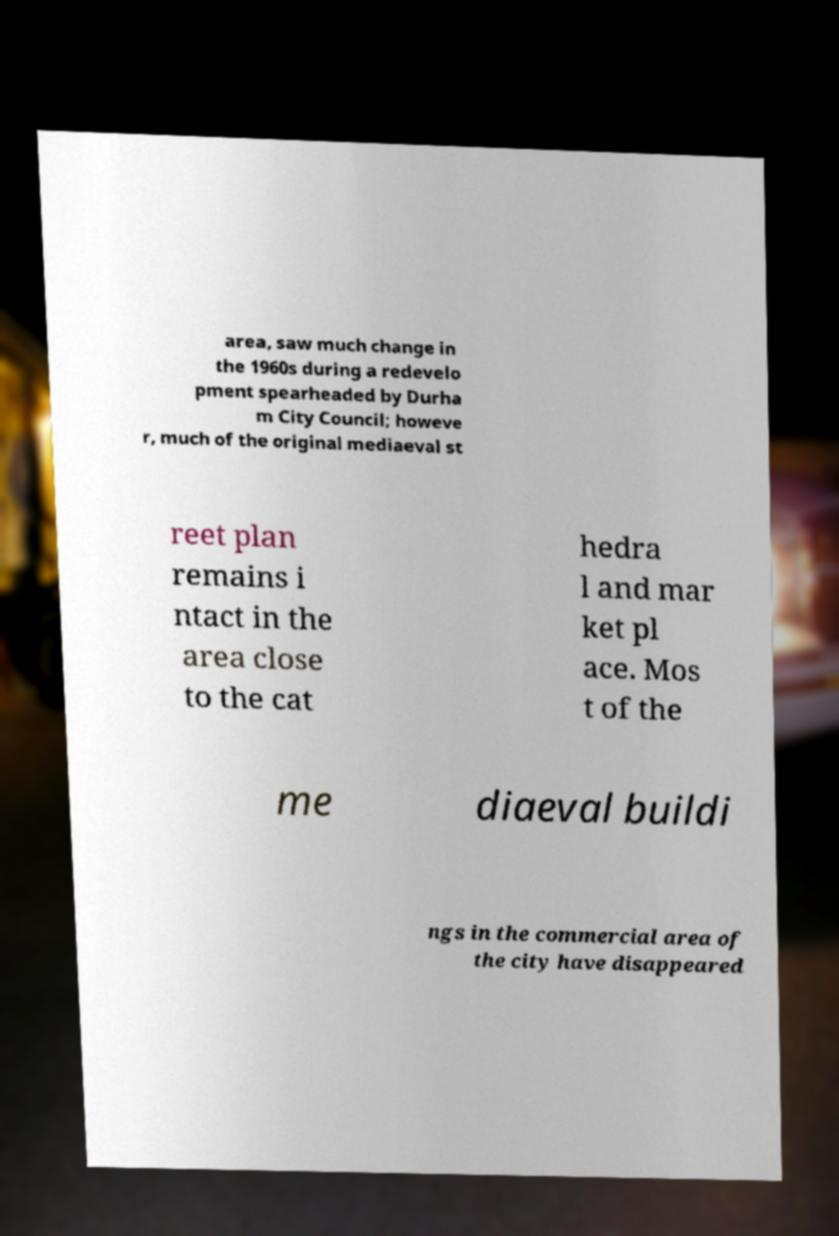Can you accurately transcribe the text from the provided image for me? area, saw much change in the 1960s during a redevelo pment spearheaded by Durha m City Council; howeve r, much of the original mediaeval st reet plan remains i ntact in the area close to the cat hedra l and mar ket pl ace. Mos t of the me diaeval buildi ngs in the commercial area of the city have disappeared 